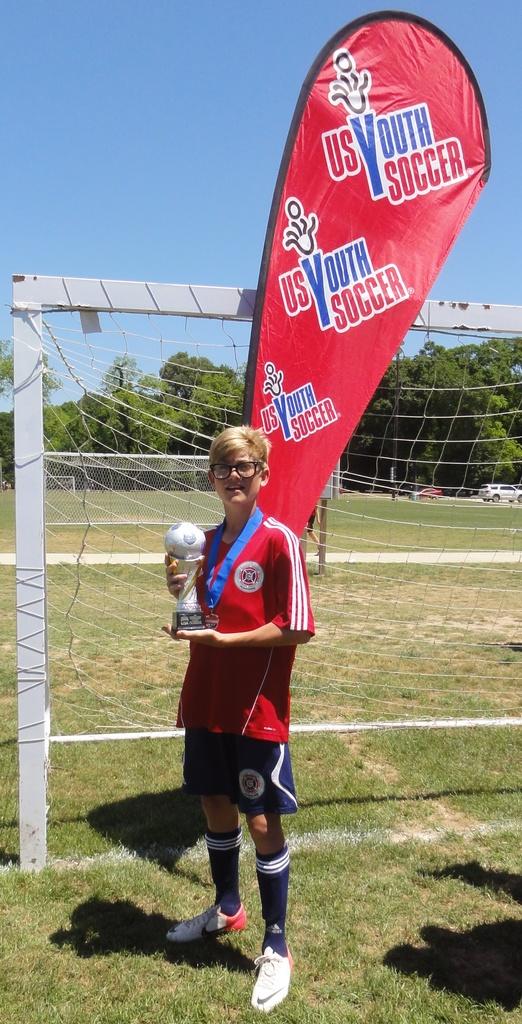What does it say on the flag behind the boy?
Provide a short and direct response. Us youth soccer. What competition did the boy win?
Ensure brevity in your answer.  Us youth soccer. 